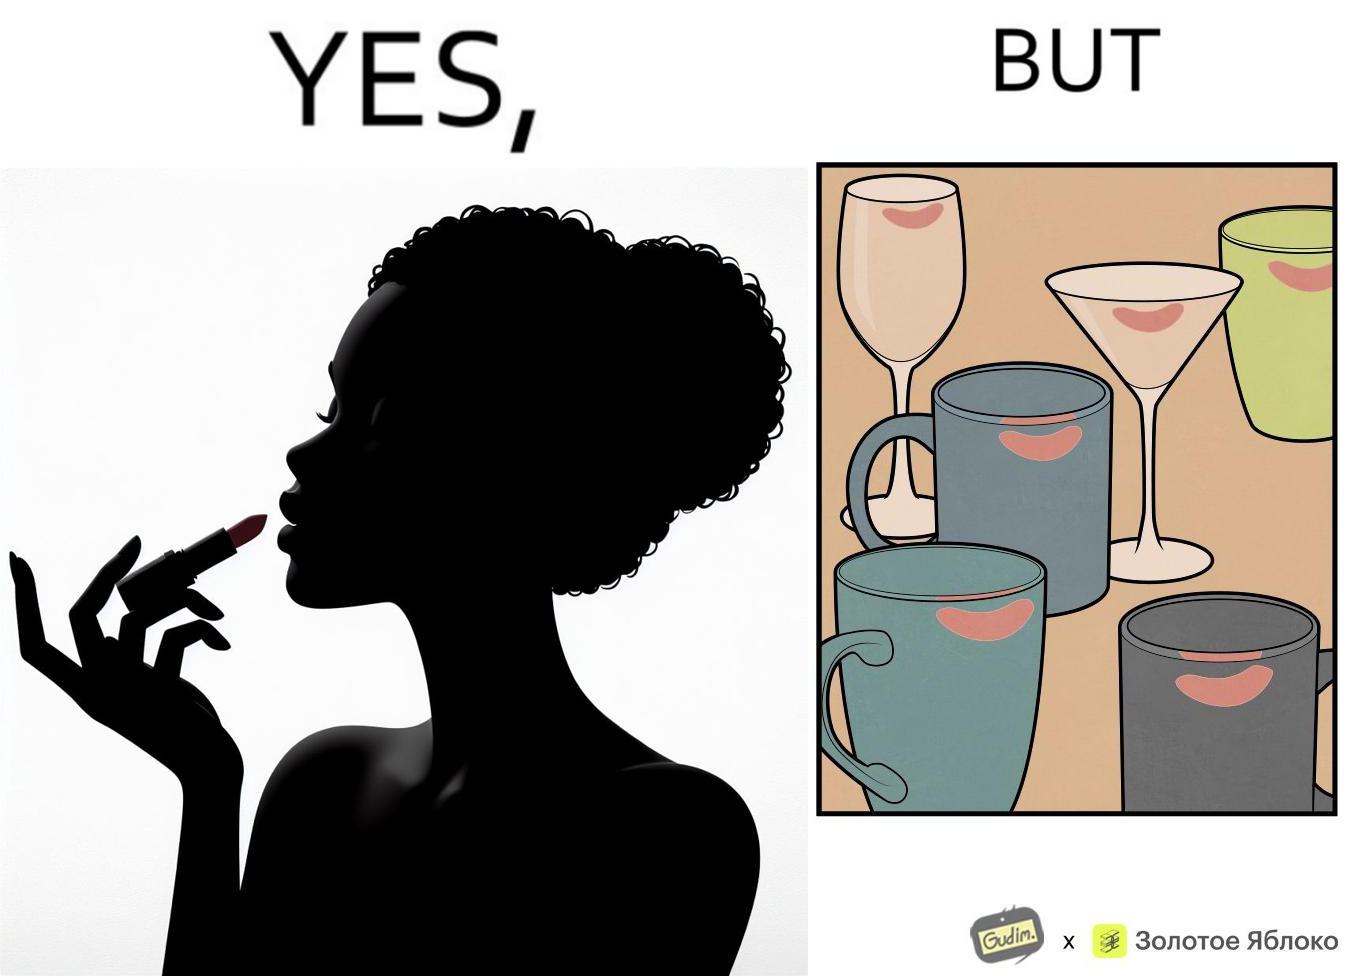Is this image satirical or non-satirical? Yes, this image is satirical. 